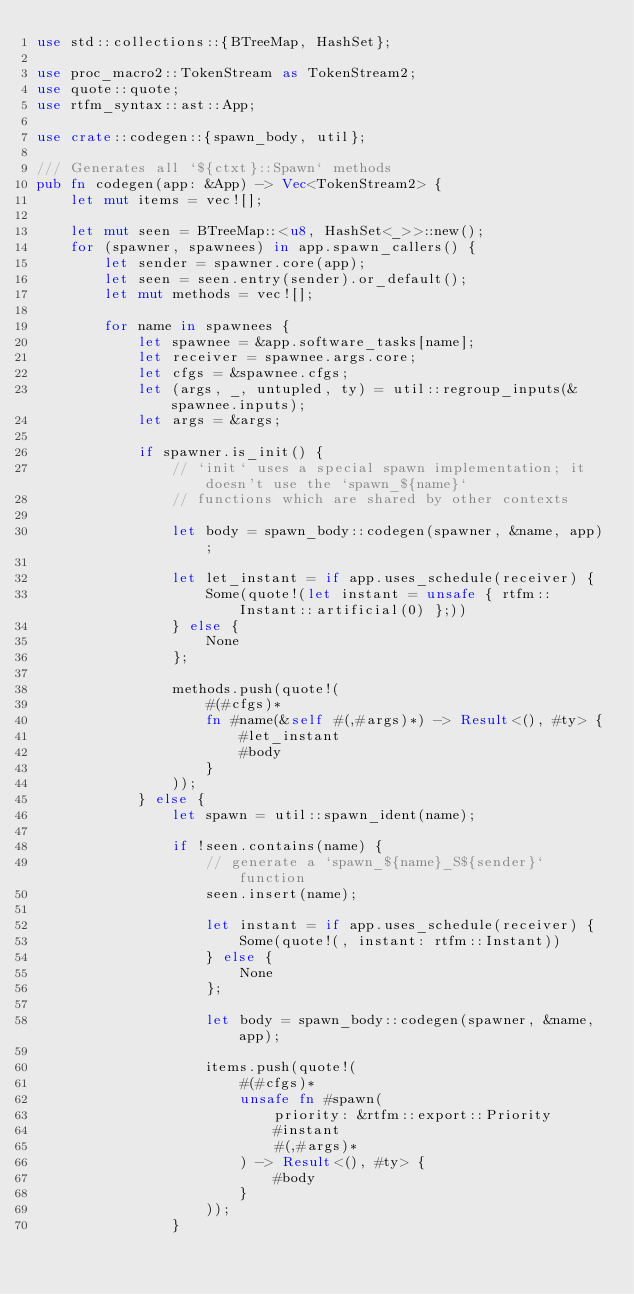<code> <loc_0><loc_0><loc_500><loc_500><_Rust_>use std::collections::{BTreeMap, HashSet};

use proc_macro2::TokenStream as TokenStream2;
use quote::quote;
use rtfm_syntax::ast::App;

use crate::codegen::{spawn_body, util};

/// Generates all `${ctxt}::Spawn` methods
pub fn codegen(app: &App) -> Vec<TokenStream2> {
    let mut items = vec![];

    let mut seen = BTreeMap::<u8, HashSet<_>>::new();
    for (spawner, spawnees) in app.spawn_callers() {
        let sender = spawner.core(app);
        let seen = seen.entry(sender).or_default();
        let mut methods = vec![];

        for name in spawnees {
            let spawnee = &app.software_tasks[name];
            let receiver = spawnee.args.core;
            let cfgs = &spawnee.cfgs;
            let (args, _, untupled, ty) = util::regroup_inputs(&spawnee.inputs);
            let args = &args;

            if spawner.is_init() {
                // `init` uses a special spawn implementation; it doesn't use the `spawn_${name}`
                // functions which are shared by other contexts

                let body = spawn_body::codegen(spawner, &name, app);

                let let_instant = if app.uses_schedule(receiver) {
                    Some(quote!(let instant = unsafe { rtfm::Instant::artificial(0) };))
                } else {
                    None
                };

                methods.push(quote!(
                    #(#cfgs)*
                    fn #name(&self #(,#args)*) -> Result<(), #ty> {
                        #let_instant
                        #body
                    }
                ));
            } else {
                let spawn = util::spawn_ident(name);

                if !seen.contains(name) {
                    // generate a `spawn_${name}_S${sender}` function
                    seen.insert(name);

                    let instant = if app.uses_schedule(receiver) {
                        Some(quote!(, instant: rtfm::Instant))
                    } else {
                        None
                    };

                    let body = spawn_body::codegen(spawner, &name, app);

                    items.push(quote!(
                        #(#cfgs)*
                        unsafe fn #spawn(
                            priority: &rtfm::export::Priority
                            #instant
                            #(,#args)*
                        ) -> Result<(), #ty> {
                            #body
                        }
                    ));
                }
</code> 